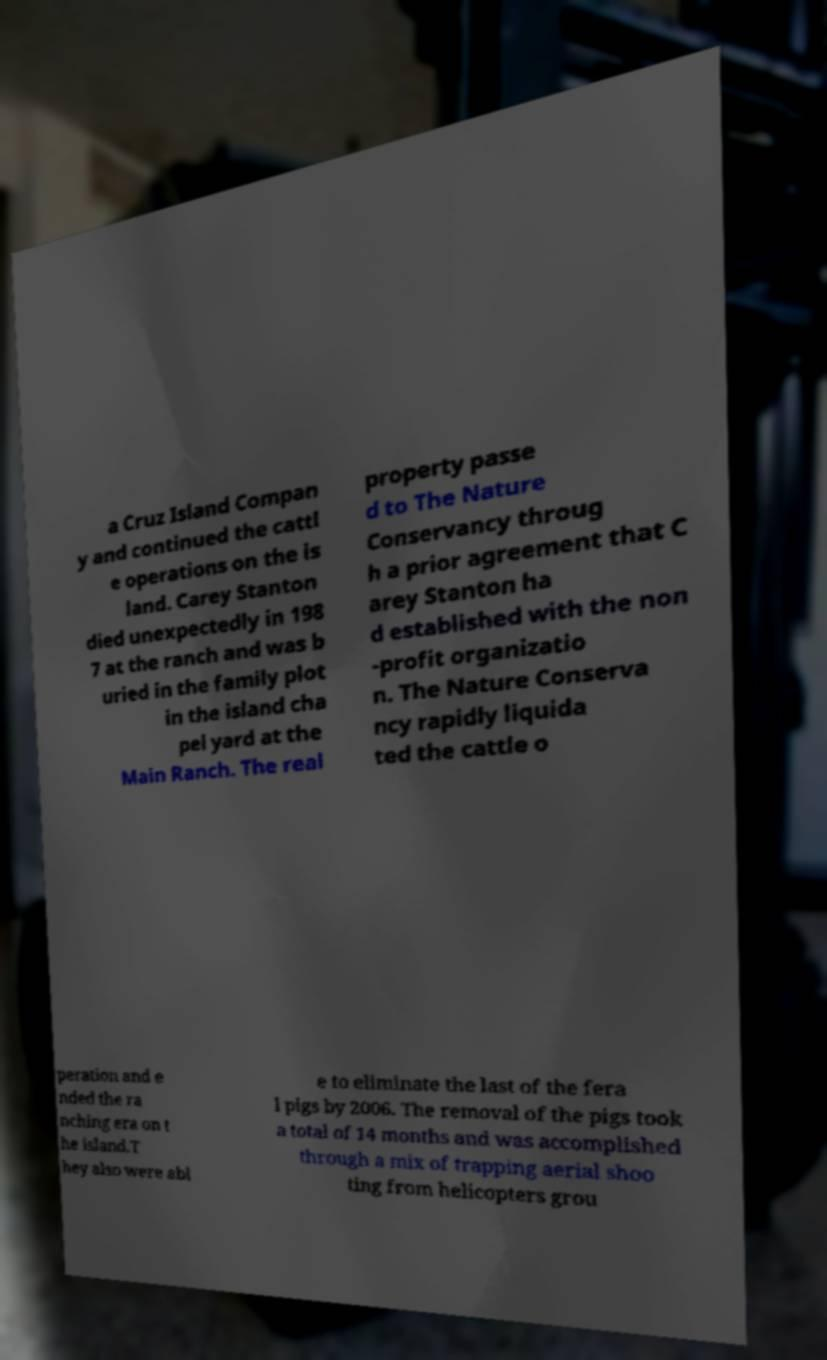Can you accurately transcribe the text from the provided image for me? a Cruz Island Compan y and continued the cattl e operations on the is land. Carey Stanton died unexpectedly in 198 7 at the ranch and was b uried in the family plot in the island cha pel yard at the Main Ranch. The real property passe d to The Nature Conservancy throug h a prior agreement that C arey Stanton ha d established with the non -profit organizatio n. The Nature Conserva ncy rapidly liquida ted the cattle o peration and e nded the ra nching era on t he island.T hey also were abl e to eliminate the last of the fera l pigs by 2006. The removal of the pigs took a total of 14 months and was accomplished through a mix of trapping aerial shoo ting from helicopters grou 